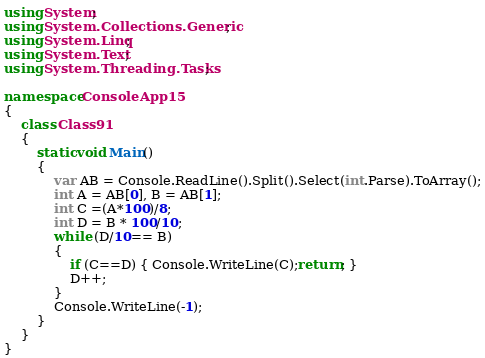Convert code to text. <code><loc_0><loc_0><loc_500><loc_500><_C#_>using System;
using System.Collections.Generic;
using System.Linq;
using System.Text;
using System.Threading.Tasks;

namespace ConsoleApp15
{
    class Class91
    {
        static void Main()
        {
            var AB = Console.ReadLine().Split().Select(int.Parse).ToArray();
            int A = AB[0], B = AB[1];
            int C =(A*100)/8;
            int D = B * 100/10;
            while (D/10== B)
            {
                if (C==D) { Console.WriteLine(C);return; }
                D++;
            }
            Console.WriteLine(-1);
        }
    }
}
</code> 